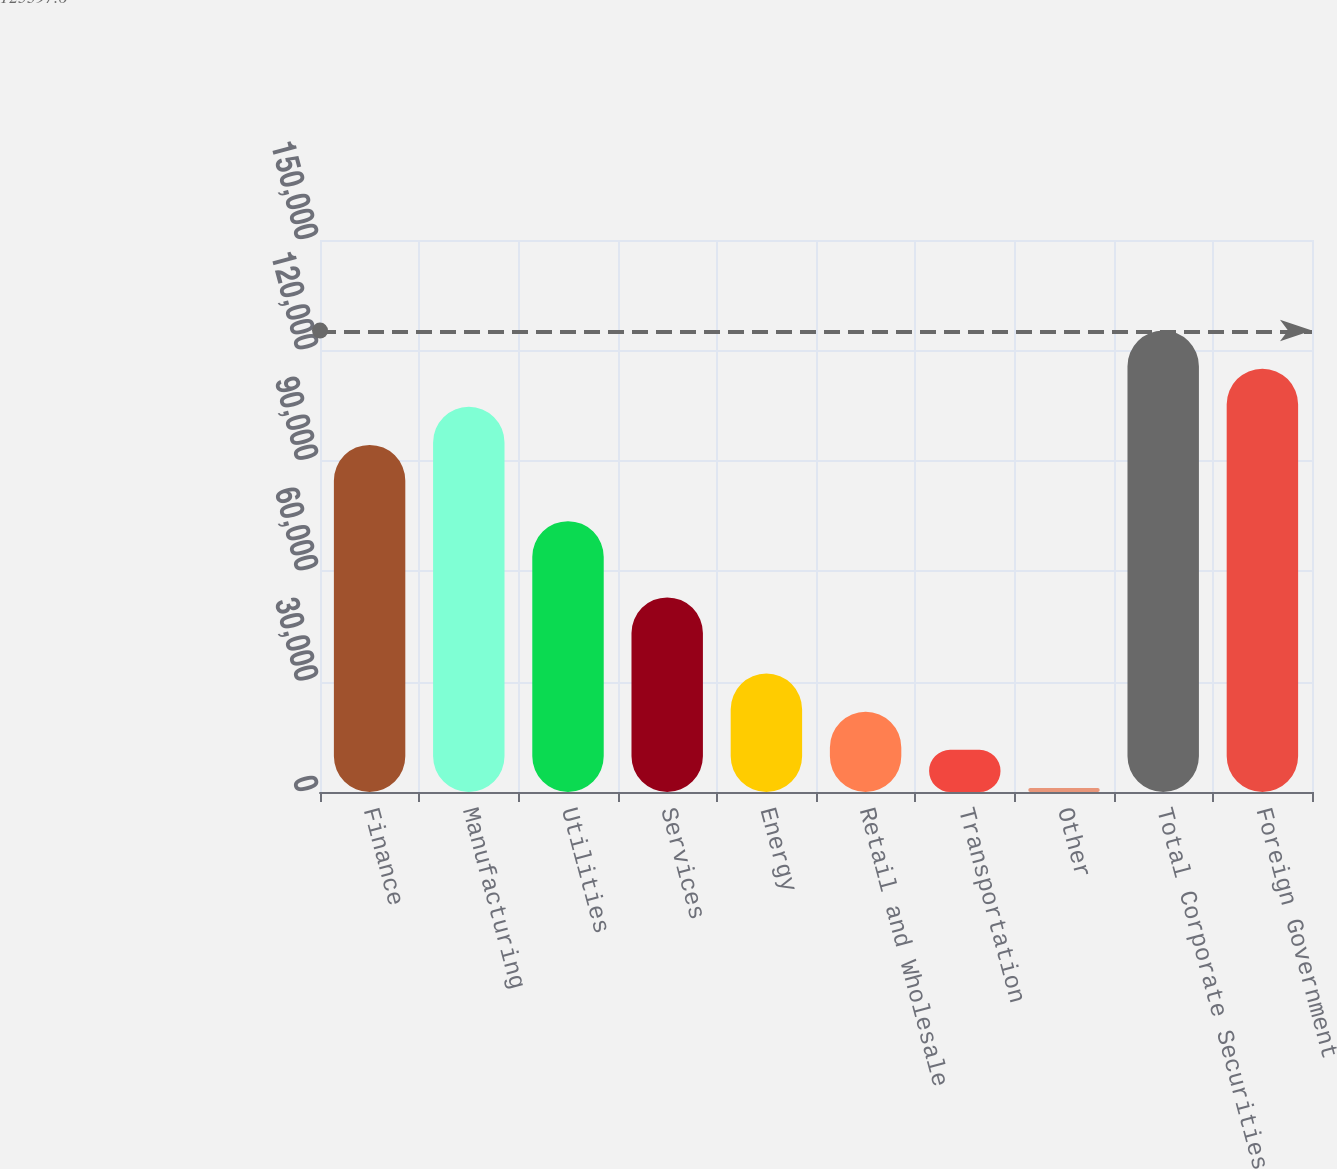Convert chart. <chart><loc_0><loc_0><loc_500><loc_500><bar_chart><fcel>Finance<fcel>Manufacturing<fcel>Utilities<fcel>Services<fcel>Energy<fcel>Retail and Wholesale<fcel>Transportation<fcel>Other<fcel>Total Corporate Securities<fcel>Foreign Government<nl><fcel>94321.2<fcel>104680<fcel>73603.6<fcel>52886<fcel>32168.4<fcel>21809.6<fcel>11450.8<fcel>1092<fcel>125398<fcel>115039<nl></chart> 